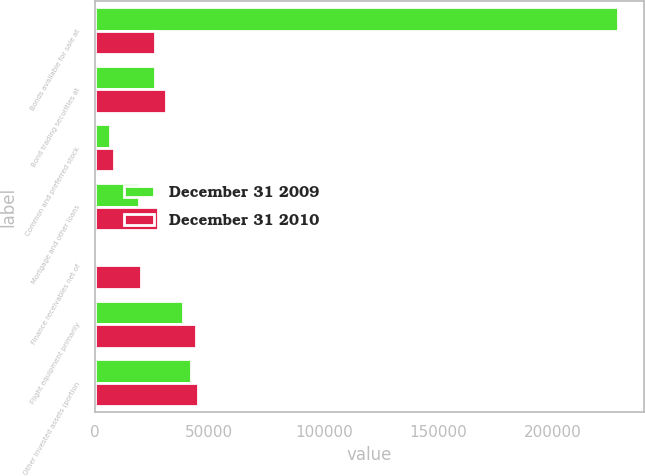<chart> <loc_0><loc_0><loc_500><loc_500><stacked_bar_chart><ecel><fcel>Bonds available for sale at<fcel>Bond trading securities at<fcel>Common and preferred stock<fcel>Mortgage and other loans<fcel>Finance receivables net of<fcel>Flight equipment primarily<fcel>Other invested assets (portion<nl><fcel>December 31 2009<fcel>228302<fcel>26182<fcel>6652<fcel>19367<fcel>870<fcel>38510<fcel>42210<nl><fcel>December 31 2010<fcel>26182<fcel>31243<fcel>8318<fcel>27461<fcel>20327<fcel>44091<fcel>45235<nl></chart> 